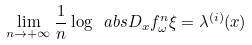<formula> <loc_0><loc_0><loc_500><loc_500>\lim _ { n \to + \infty } \frac { 1 } { n } \log \ a b s { D _ { x } f ^ { n } _ { \omega } \xi } = \lambda ^ { ( i ) } ( x )</formula> 